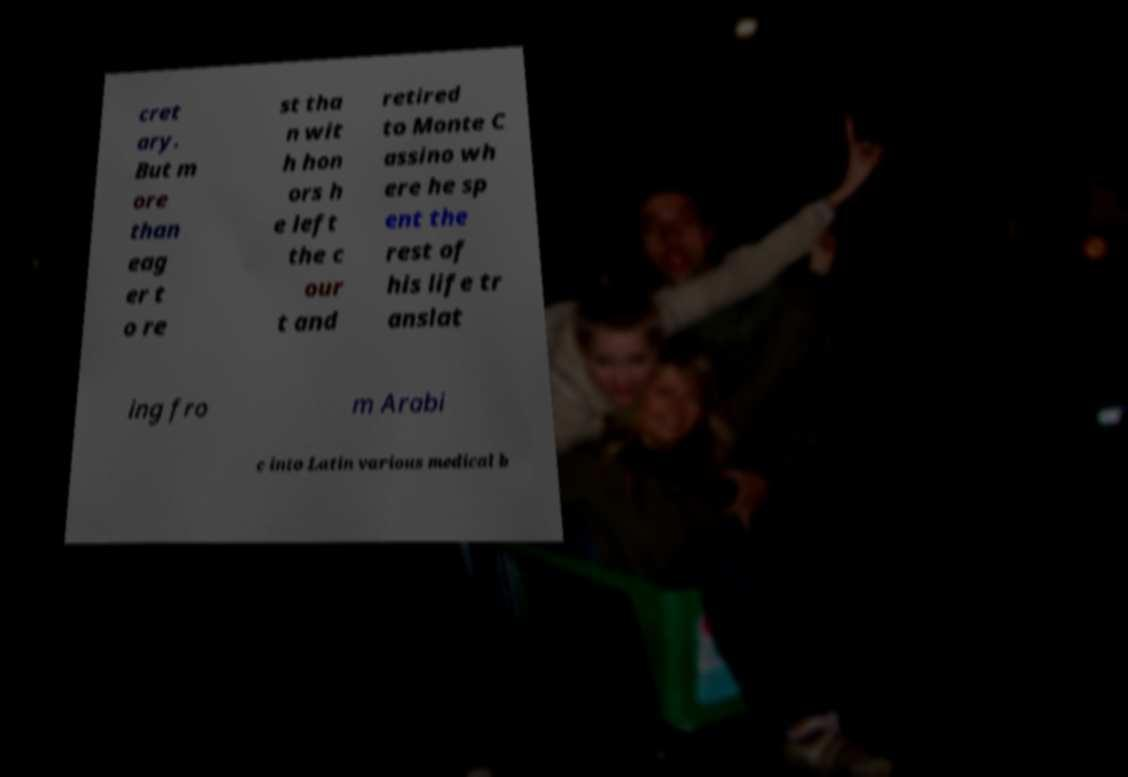Can you accurately transcribe the text from the provided image for me? cret ary. But m ore than eag er t o re st tha n wit h hon ors h e left the c our t and retired to Monte C assino wh ere he sp ent the rest of his life tr anslat ing fro m Arabi c into Latin various medical b 